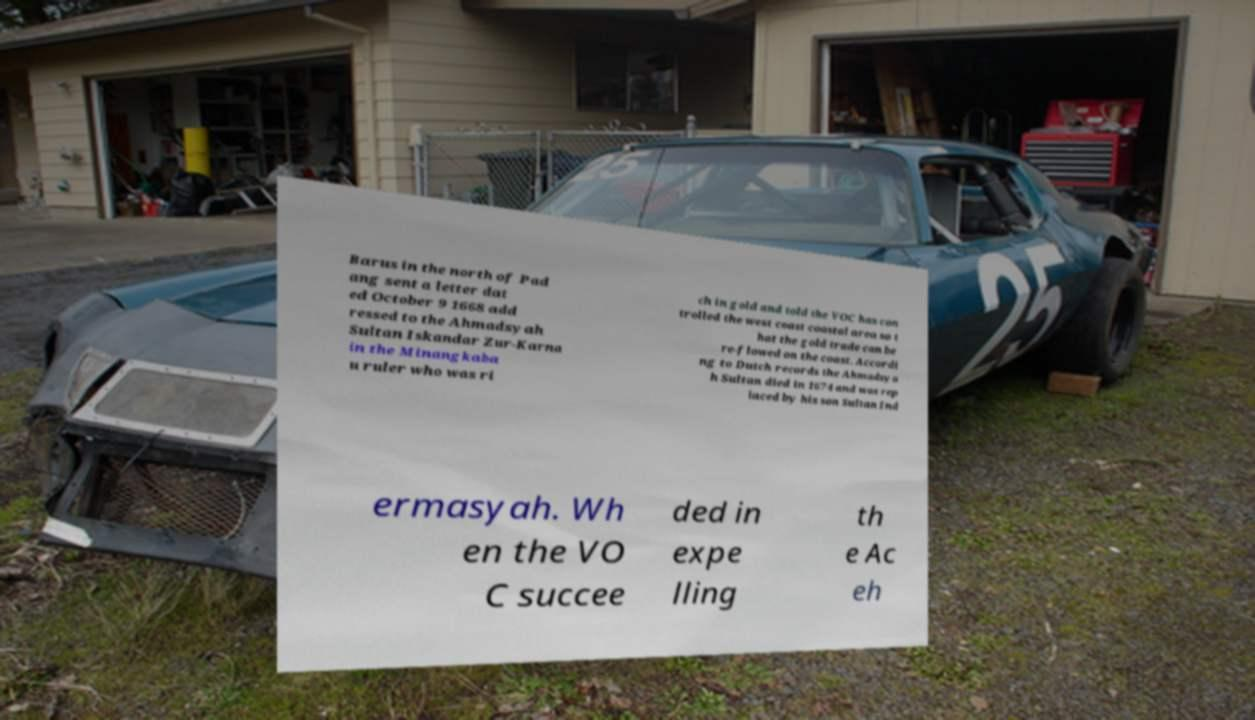Could you assist in decoding the text presented in this image and type it out clearly? Barus in the north of Pad ang sent a letter dat ed October 9 1668 add ressed to the Ahmadsyah Sultan Iskandar Zur-Karna in the Minangkaba u ruler who was ri ch in gold and told the VOC has con trolled the west coast coastal area so t hat the gold trade can be re-flowed on the coast. Accordi ng to Dutch records the Ahmadsya h Sultan died in 1674 and was rep laced by his son Sultan Ind ermasyah. Wh en the VO C succee ded in expe lling th e Ac eh 